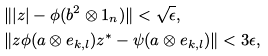Convert formula to latex. <formula><loc_0><loc_0><loc_500><loc_500>& \| | z | - \phi ( b ^ { 2 } \otimes 1 _ { n } ) \| < \sqrt { \epsilon } , \\ & \| z \phi ( a \otimes e _ { k , l } ) z ^ { * } - \psi ( a \otimes e _ { k , l } ) \| < 3 \epsilon ,</formula> 